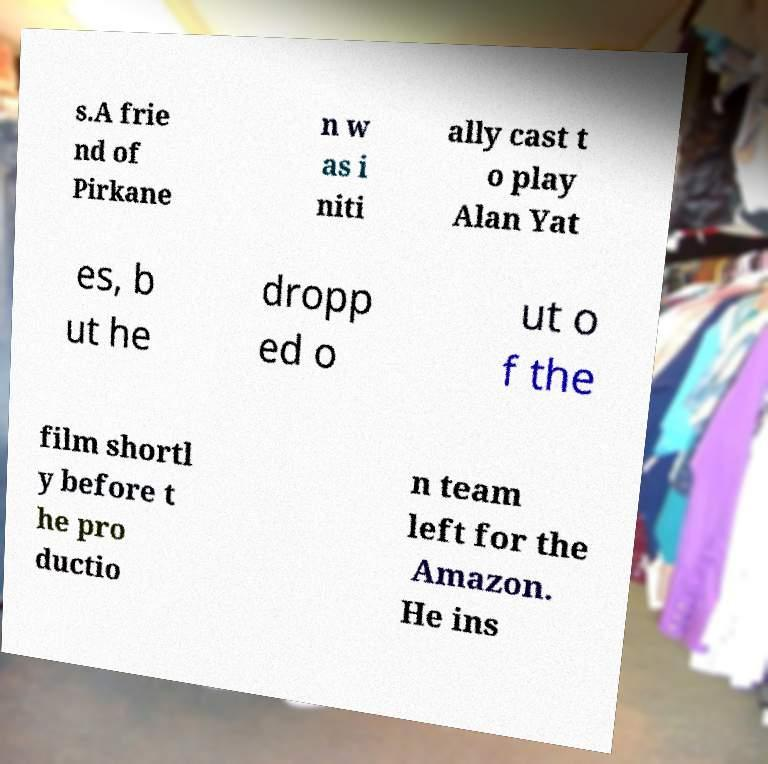Please identify and transcribe the text found in this image. s.A frie nd of Pirkane n w as i niti ally cast t o play Alan Yat es, b ut he dropp ed o ut o f the film shortl y before t he pro ductio n team left for the Amazon. He ins 